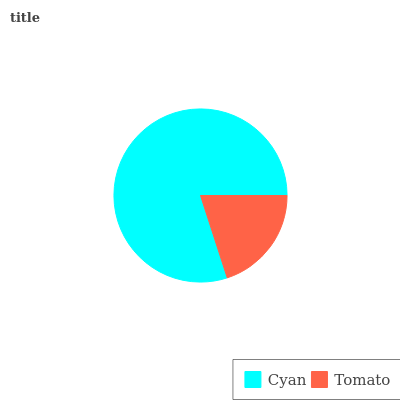Is Tomato the minimum?
Answer yes or no. Yes. Is Cyan the maximum?
Answer yes or no. Yes. Is Tomato the maximum?
Answer yes or no. No. Is Cyan greater than Tomato?
Answer yes or no. Yes. Is Tomato less than Cyan?
Answer yes or no. Yes. Is Tomato greater than Cyan?
Answer yes or no. No. Is Cyan less than Tomato?
Answer yes or no. No. Is Cyan the high median?
Answer yes or no. Yes. Is Tomato the low median?
Answer yes or no. Yes. Is Tomato the high median?
Answer yes or no. No. Is Cyan the low median?
Answer yes or no. No. 